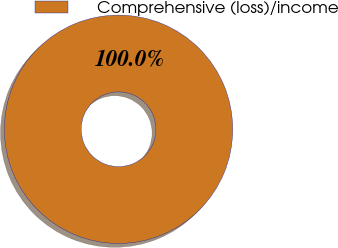Convert chart to OTSL. <chart><loc_0><loc_0><loc_500><loc_500><pie_chart><fcel>Comprehensive (loss)/income<nl><fcel>100.0%<nl></chart> 